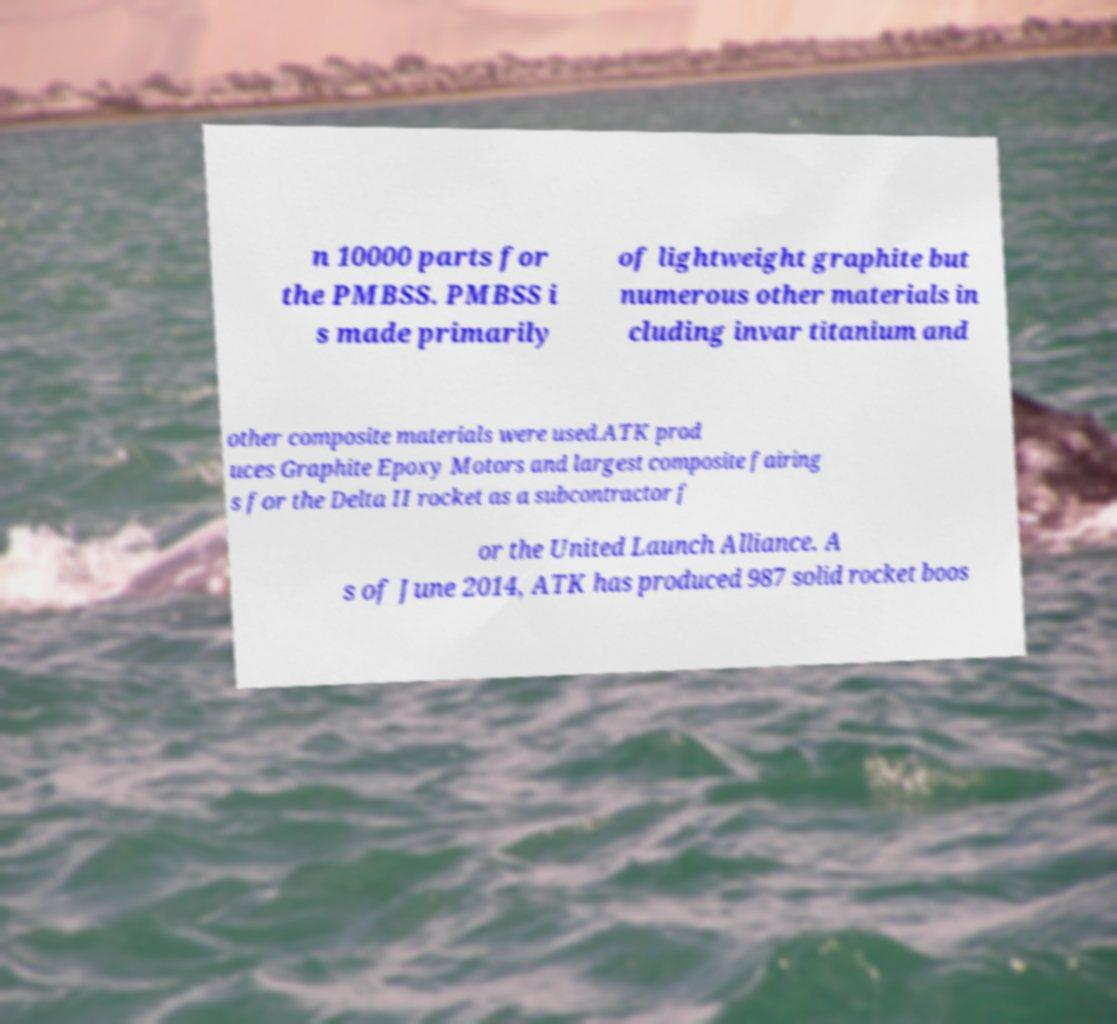There's text embedded in this image that I need extracted. Can you transcribe it verbatim? n 10000 parts for the PMBSS. PMBSS i s made primarily of lightweight graphite but numerous other materials in cluding invar titanium and other composite materials were used.ATK prod uces Graphite Epoxy Motors and largest composite fairing s for the Delta II rocket as a subcontractor f or the United Launch Alliance. A s of June 2014, ATK has produced 987 solid rocket boos 